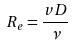Convert formula to latex. <formula><loc_0><loc_0><loc_500><loc_500>R _ { e } = \frac { v D } { \nu }</formula> 